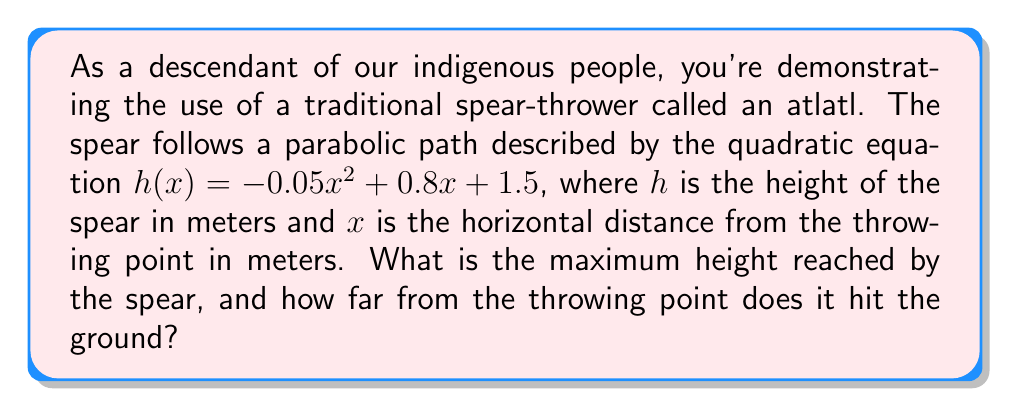Can you answer this question? Let's approach this problem step-by-step:

1) The quadratic equation is in the form $h(x) = ax^2 + bx + c$, where:
   $a = -0.05$
   $b = 0.8$
   $c = 1.5$

2) To find the maximum height, we need to find the vertex of the parabola. The x-coordinate of the vertex is given by $x = -\frac{b}{2a}$:

   $x = -\frac{0.8}{2(-0.05)} = -\frac{0.8}{-0.1} = 8$ meters

3) To find the maximum height, we substitute this x-value into the original equation:

   $h(8) = -0.05(8)^2 + 0.8(8) + 1.5$
         $= -0.05(64) + 6.4 + 1.5$
         $= -3.2 + 6.4 + 1.5$
         $= 4.7$ meters

4) To find where the spear hits the ground, we need to find the roots of the equation. This is where $h(x) = 0$:

   $0 = -0.05x^2 + 0.8x + 1.5$

5) We can solve this using the quadratic formula: $x = \frac{-b \pm \sqrt{b^2 - 4ac}}{2a}$

   $x = \frac{-0.8 \pm \sqrt{0.8^2 - 4(-0.05)(1.5)}}{2(-0.05)}$

6) Simplifying:

   $x = \frac{-0.8 \pm \sqrt{0.64 + 0.3}}{-0.1} = \frac{-0.8 \pm \sqrt{0.94}}{-0.1} = \frac{-0.8 \pm 0.97}{-0.1}$

7) This gives us two solutions:
   $x_1 = \frac{-0.8 + 0.97}{-0.1} = -1.7$ (we can discard this negative solution)
   $x_2 = \frac{-0.8 - 0.97}{-0.1} = 17.7$

Therefore, the spear hits the ground approximately 17.7 meters from the throwing point.
Answer: The maximum height reached by the spear is 4.7 meters, and it hits the ground approximately 17.7 meters from the throwing point. 